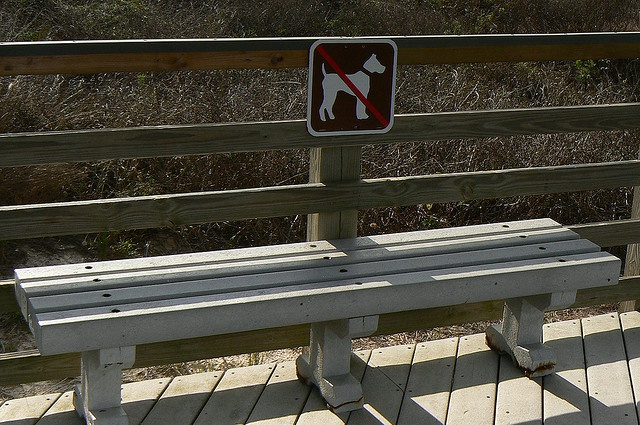Describe the objects in this image and their specific colors. I can see bench in black, gray, ivory, and darkgray tones and dog in black and gray tones in this image. 